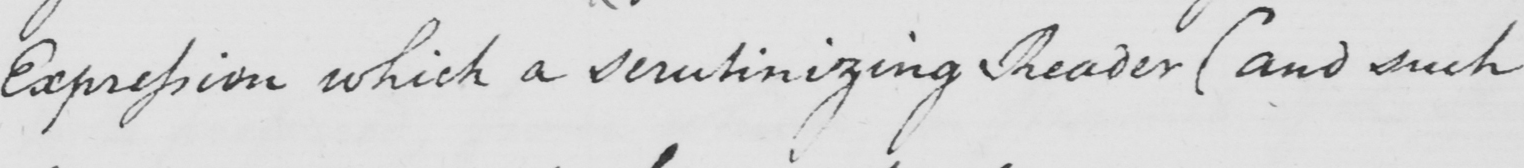Can you read and transcribe this handwriting? Expression which a scrutinizing Reader  ( and such 